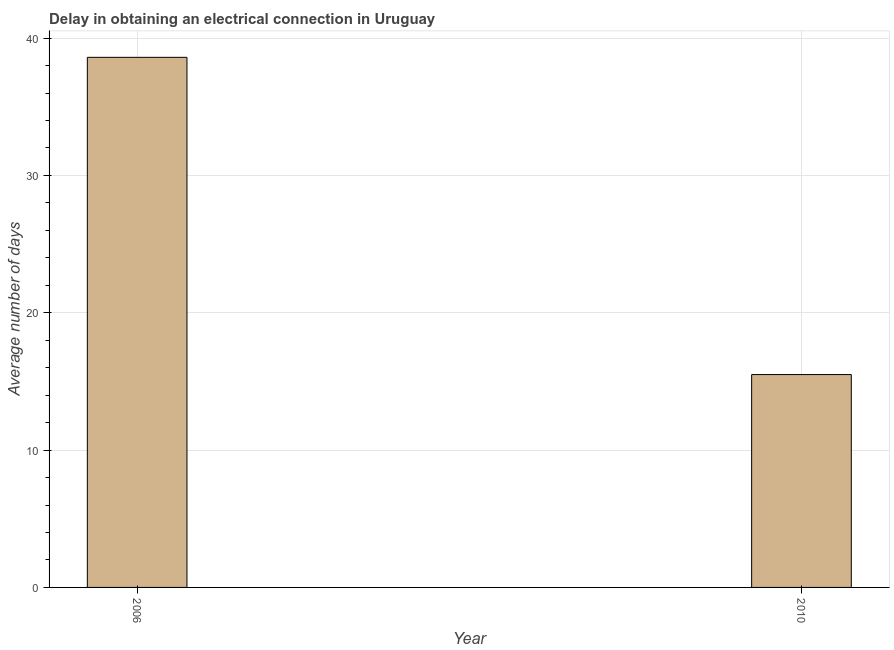Does the graph contain any zero values?
Offer a very short reply. No. What is the title of the graph?
Your answer should be compact. Delay in obtaining an electrical connection in Uruguay. What is the label or title of the X-axis?
Your answer should be compact. Year. What is the label or title of the Y-axis?
Make the answer very short. Average number of days. What is the dalay in electrical connection in 2006?
Your answer should be very brief. 38.6. Across all years, what is the maximum dalay in electrical connection?
Offer a very short reply. 38.6. In which year was the dalay in electrical connection maximum?
Your answer should be compact. 2006. In which year was the dalay in electrical connection minimum?
Offer a very short reply. 2010. What is the sum of the dalay in electrical connection?
Keep it short and to the point. 54.1. What is the difference between the dalay in electrical connection in 2006 and 2010?
Give a very brief answer. 23.1. What is the average dalay in electrical connection per year?
Provide a succinct answer. 27.05. What is the median dalay in electrical connection?
Your response must be concise. 27.05. In how many years, is the dalay in electrical connection greater than 26 days?
Ensure brevity in your answer.  1. What is the ratio of the dalay in electrical connection in 2006 to that in 2010?
Make the answer very short. 2.49. In how many years, is the dalay in electrical connection greater than the average dalay in electrical connection taken over all years?
Offer a terse response. 1. Are all the bars in the graph horizontal?
Give a very brief answer. No. What is the difference between two consecutive major ticks on the Y-axis?
Your response must be concise. 10. What is the Average number of days of 2006?
Give a very brief answer. 38.6. What is the difference between the Average number of days in 2006 and 2010?
Offer a terse response. 23.1. What is the ratio of the Average number of days in 2006 to that in 2010?
Provide a succinct answer. 2.49. 